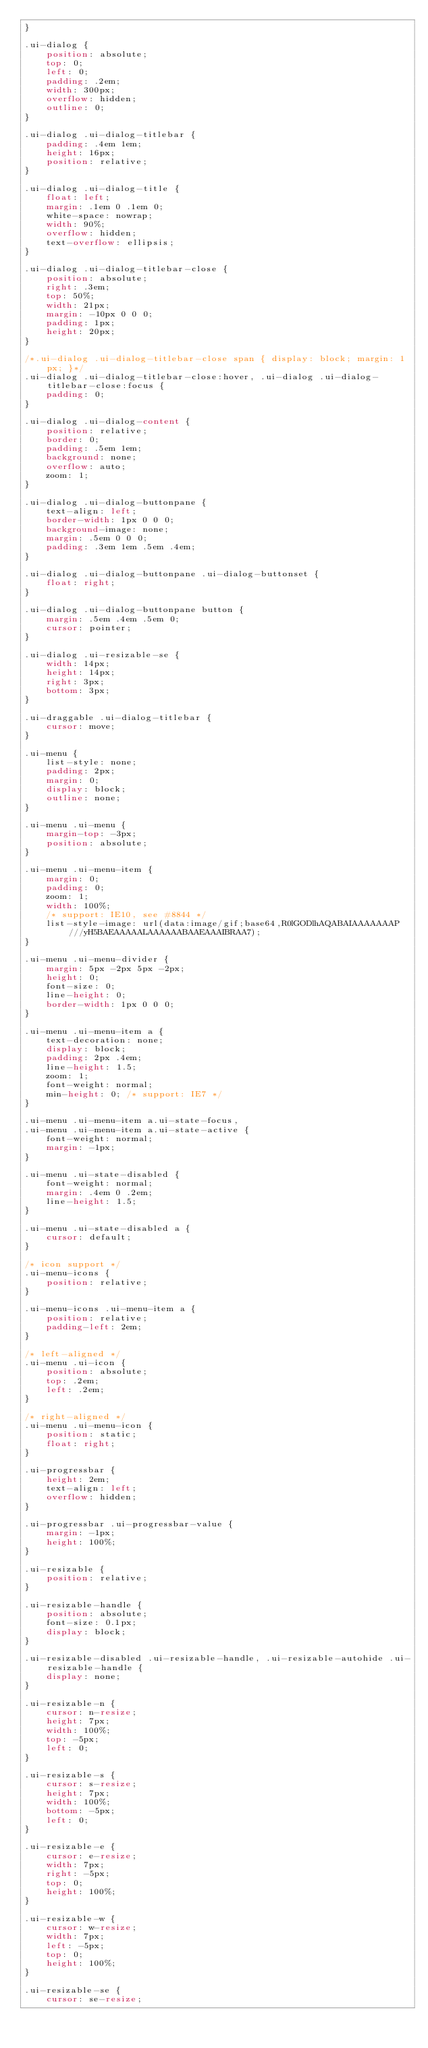Convert code to text. <code><loc_0><loc_0><loc_500><loc_500><_CSS_>}

.ui-dialog {
    position: absolute;
    top: 0;
    left: 0;
    padding: .2em;
    width: 300px;
    overflow: hidden;
    outline: 0;
}

.ui-dialog .ui-dialog-titlebar {
    padding: .4em 1em;
    height: 16px;
    position: relative;
}

.ui-dialog .ui-dialog-title {
    float: left;
    margin: .1em 0 .1em 0;
    white-space: nowrap;
    width: 90%;
    overflow: hidden;
    text-overflow: ellipsis;
}

.ui-dialog .ui-dialog-titlebar-close {
    position: absolute;
    right: .3em;
    top: 50%;
    width: 21px;
    margin: -10px 0 0 0;
    padding: 1px;
    height: 20px;
}

/*.ui-dialog .ui-dialog-titlebar-close span { display: block; margin: 1px; }*/
.ui-dialog .ui-dialog-titlebar-close:hover, .ui-dialog .ui-dialog-titlebar-close:focus {
    padding: 0;
}

.ui-dialog .ui-dialog-content {
    position: relative;
    border: 0;
    padding: .5em 1em;
    background: none;
    overflow: auto;
    zoom: 1;
}

.ui-dialog .ui-dialog-buttonpane {
    text-align: left;
    border-width: 1px 0 0 0;
    background-image: none;
    margin: .5em 0 0 0;
    padding: .3em 1em .5em .4em;
}

.ui-dialog .ui-dialog-buttonpane .ui-dialog-buttonset {
    float: right;
}

.ui-dialog .ui-dialog-buttonpane button {
    margin: .5em .4em .5em 0;
    cursor: pointer;
}

.ui-dialog .ui-resizable-se {
    width: 14px;
    height: 14px;
    right: 3px;
    bottom: 3px;
}

.ui-draggable .ui-dialog-titlebar {
    cursor: move;
}

.ui-menu {
    list-style: none;
    padding: 2px;
    margin: 0;
    display: block;
    outline: none;
}

.ui-menu .ui-menu {
    margin-top: -3px;
    position: absolute;
}

.ui-menu .ui-menu-item {
    margin: 0;
    padding: 0;
    zoom: 1;
    width: 100%;
    /* support: IE10, see #8844 */
    list-style-image: url(data:image/gif;base64,R0lGODlhAQABAIAAAAAAAP///yH5BAEAAAAALAAAAAABAAEAAAIBRAA7);
}

.ui-menu .ui-menu-divider {
    margin: 5px -2px 5px -2px;
    height: 0;
    font-size: 0;
    line-height: 0;
    border-width: 1px 0 0 0;
}

.ui-menu .ui-menu-item a {
    text-decoration: none;
    display: block;
    padding: 2px .4em;
    line-height: 1.5;
    zoom: 1;
    font-weight: normal;
    min-height: 0; /* support: IE7 */
}

.ui-menu .ui-menu-item a.ui-state-focus,
.ui-menu .ui-menu-item a.ui-state-active {
    font-weight: normal;
    margin: -1px;
}

.ui-menu .ui-state-disabled {
    font-weight: normal;
    margin: .4em 0 .2em;
    line-height: 1.5;
}

.ui-menu .ui-state-disabled a {
    cursor: default;
}

/* icon support */
.ui-menu-icons {
    position: relative;
}

.ui-menu-icons .ui-menu-item a {
    position: relative;
    padding-left: 2em;
}

/* left-aligned */
.ui-menu .ui-icon {
    position: absolute;
    top: .2em;
    left: .2em;
}

/* right-aligned */
.ui-menu .ui-menu-icon {
    position: static;
    float: right;
}

.ui-progressbar {
    height: 2em;
    text-align: left;
    overflow: hidden;
}

.ui-progressbar .ui-progressbar-value {
    margin: -1px;
    height: 100%;
}

.ui-resizable {
    position: relative;
}

.ui-resizable-handle {
    position: absolute;
    font-size: 0.1px;
    display: block;
}

.ui-resizable-disabled .ui-resizable-handle, .ui-resizable-autohide .ui-resizable-handle {
    display: none;
}

.ui-resizable-n {
    cursor: n-resize;
    height: 7px;
    width: 100%;
    top: -5px;
    left: 0;
}

.ui-resizable-s {
    cursor: s-resize;
    height: 7px;
    width: 100%;
    bottom: -5px;
    left: 0;
}

.ui-resizable-e {
    cursor: e-resize;
    width: 7px;
    right: -5px;
    top: 0;
    height: 100%;
}

.ui-resizable-w {
    cursor: w-resize;
    width: 7px;
    left: -5px;
    top: 0;
    height: 100%;
}

.ui-resizable-se {
    cursor: se-resize;</code> 